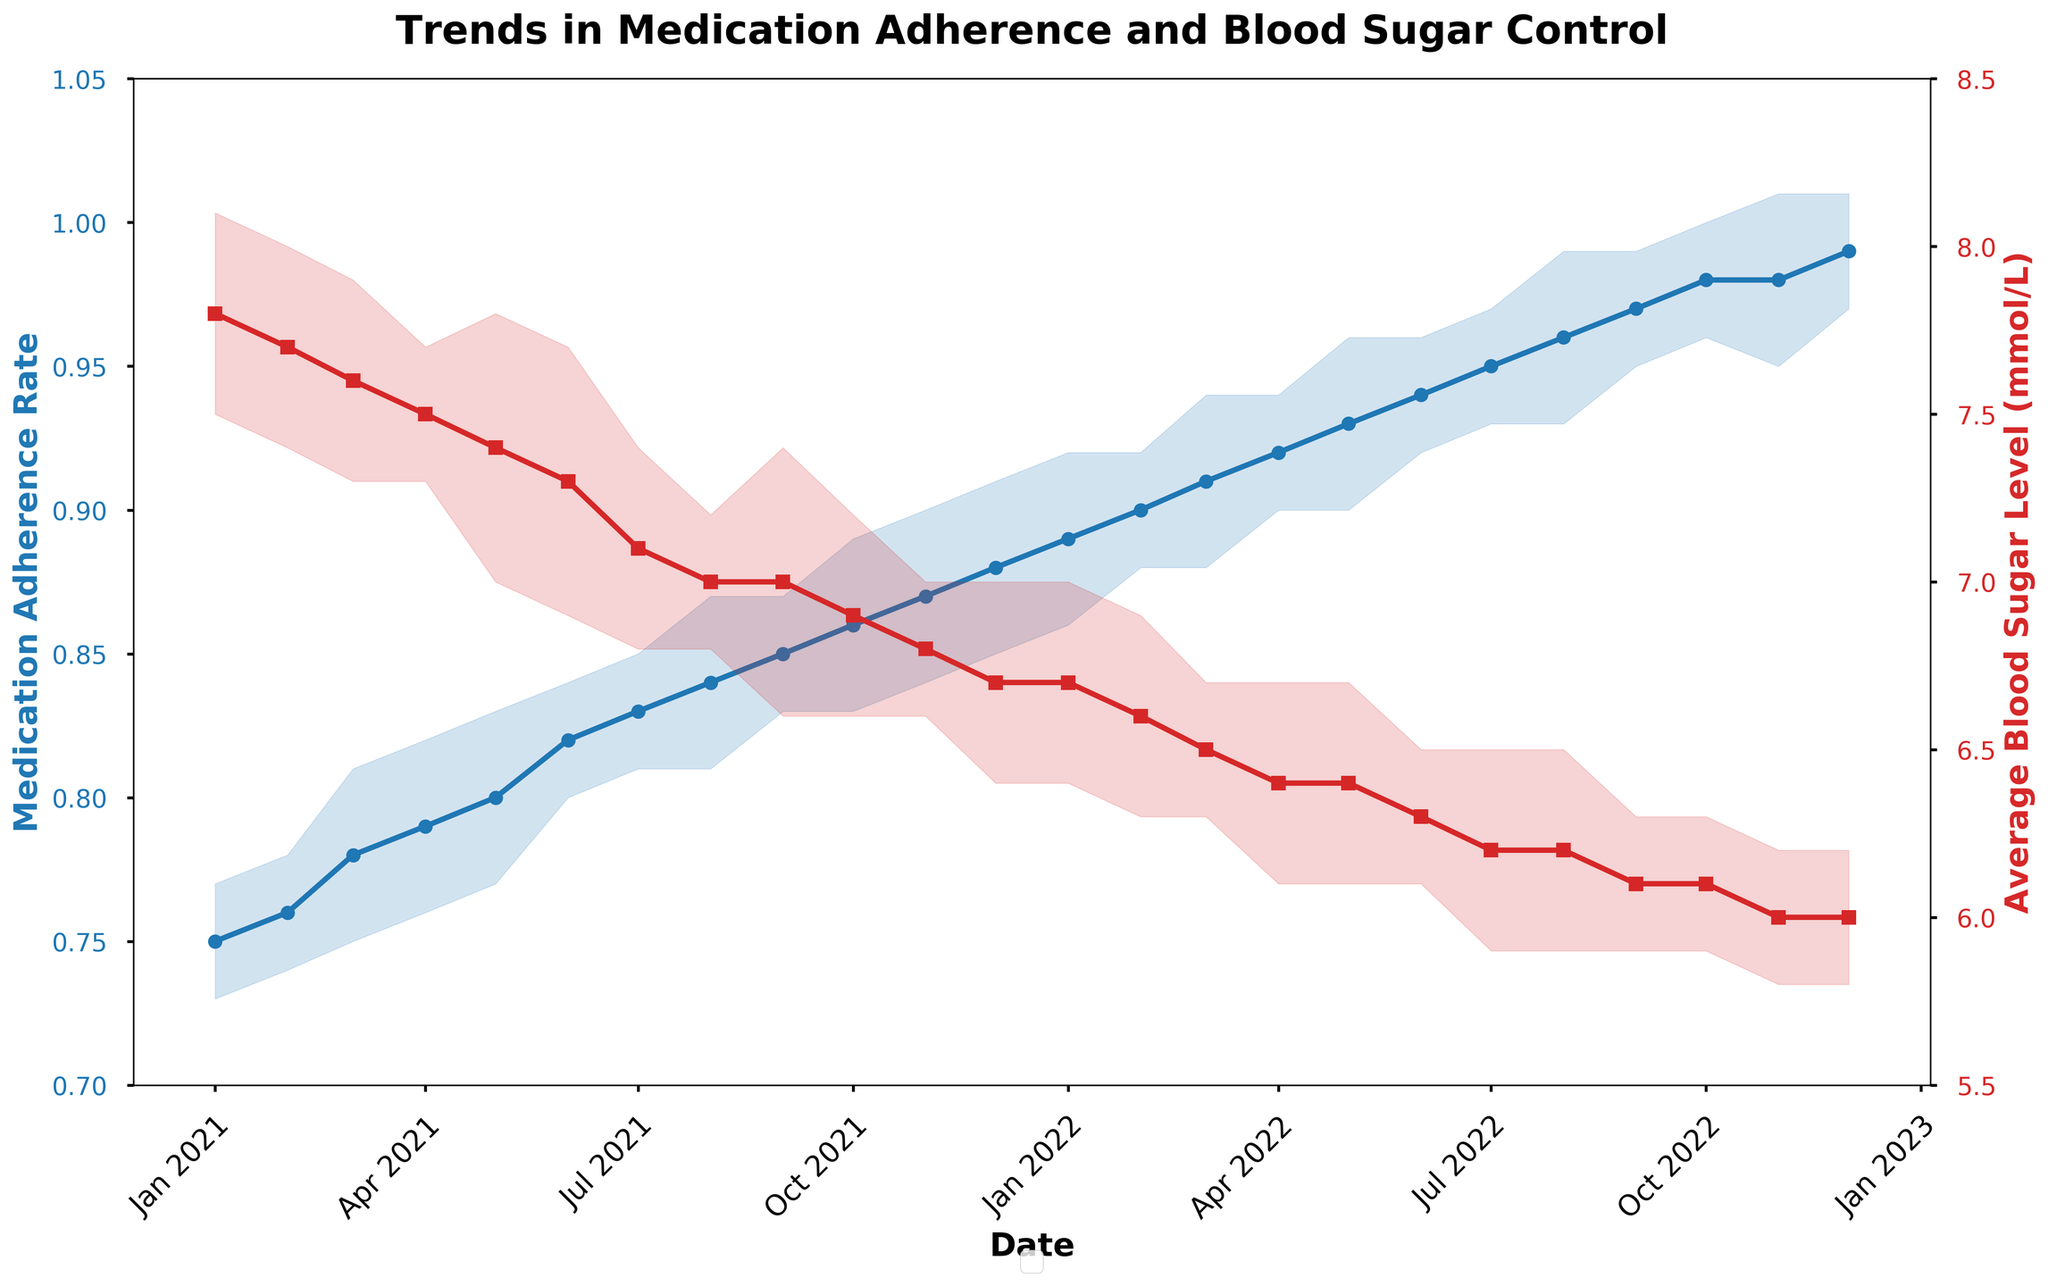What's the title of the plot? The title of the plot is written at the top center of the figure.
Answer: Trends in Medication Adherence and Blood Sugar Control What does the blue line represent? The blue line represents the data associated with the y-axis on the left, which displays Medication Adherence Rate.
Answer: Medication Adherence Rate Between which months did the average blood sugar level show the steepest decline? To identify the steepest decline, observe the red line and find where the slope is steepest. The steepest decline occurs between Jun 2021 and Jul 2021.
Answer: Jun 2021 to Jul 2021 What are the error margins for medication adherence rate in May 2022? To find the error margins, look for May 2022 in the dataset and refer to Error_Margin_Adherence.
Answer: +/- 0.03 How did the blood sugar levels change from December 2021 to January 2022? Check the red line at the points corresponding to December 2021 and January 2022. Both the points have the same value of 6.7 mmol/L.
Answer: It stayed the same Which month in 2022 had the highest medication adherence rate? Look at the blue line for 2022 and identify the peak value. The highest medication adherence rate was 0.99, which occurred in December 2022.
Answer: December 2022 Is there a correlation between medication adherence rate and average blood sugar level? Notice the trend between the blue and red lines. As the medication adherence rate increases, the average blood sugar level decreases, suggesting a negative correlation.
Answer: Yes, there's a negative correlation What is the range of average blood sugar levels observed in the figure? Observe the highest peak and lowest value on the red line to determine the range. The highest is 7.8 mmol/L in January 2021, and the lowest is 6.0 mmol/L in December 2022. The range is 7.8 - 6.0 = 1.8
Answer: 1.8 mmol/L Between which months did the medication adherence rate see its largest increase? Find the months with the largest difference in the blue line. The rate increased from 0.97 in September 2022 to 0.98 in October 2022.
Answer: September 2022 to October 2022 